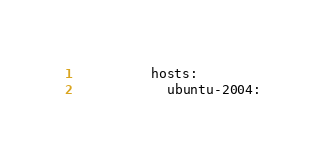Convert code to text. <code><loc_0><loc_0><loc_500><loc_500><_YAML_>          hosts:
            ubuntu-2004:
</code> 